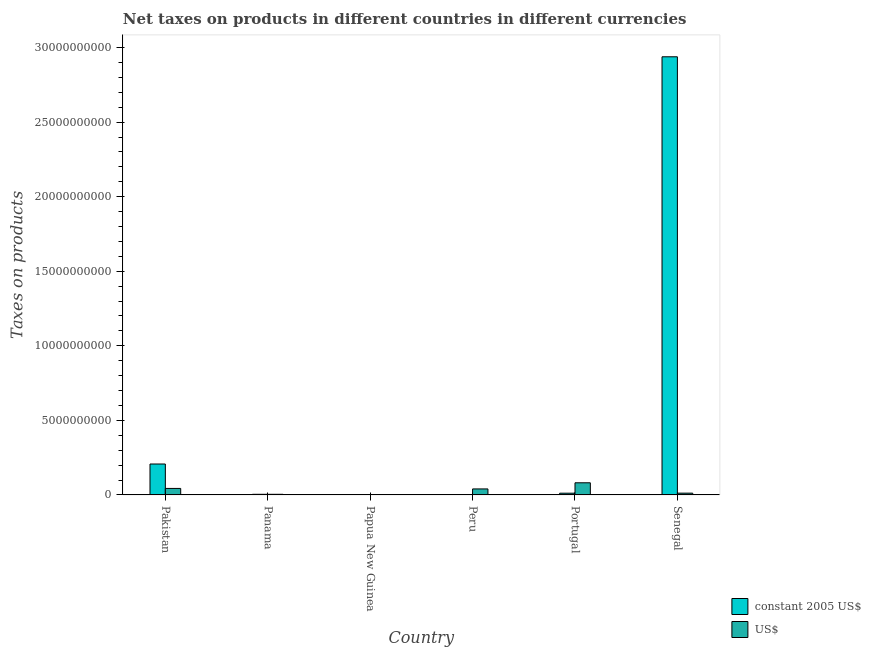How many different coloured bars are there?
Offer a terse response. 2. How many bars are there on the 3rd tick from the left?
Provide a short and direct response. 2. What is the label of the 6th group of bars from the left?
Make the answer very short. Senegal. In how many cases, is the number of bars for a given country not equal to the number of legend labels?
Your answer should be compact. 0. What is the net taxes in constant 2005 us$ in Panama?
Provide a short and direct response. 4.20e+07. Across all countries, what is the maximum net taxes in us$?
Provide a succinct answer. 8.14e+08. Across all countries, what is the minimum net taxes in constant 2005 us$?
Your answer should be compact. 10.8. In which country was the net taxes in us$ maximum?
Your answer should be very brief. Portugal. In which country was the net taxes in us$ minimum?
Make the answer very short. Papua New Guinea. What is the total net taxes in us$ in the graph?
Offer a very short reply. 1.83e+09. What is the difference between the net taxes in us$ in Papua New Guinea and that in Peru?
Make the answer very short. -3.91e+08. What is the difference between the net taxes in constant 2005 us$ in Portugal and the net taxes in us$ in Papua New Guinea?
Offer a terse response. 1.05e+08. What is the average net taxes in constant 2005 us$ per country?
Keep it short and to the point. 5.27e+09. What is the difference between the net taxes in us$ and net taxes in constant 2005 us$ in Portugal?
Give a very brief answer. 6.98e+08. In how many countries, is the net taxes in constant 2005 us$ greater than 18000000000 units?
Offer a terse response. 1. What is the ratio of the net taxes in constant 2005 us$ in Peru to that in Senegal?
Offer a very short reply. 3.675817024414191e-10. Is the difference between the net taxes in constant 2005 us$ in Papua New Guinea and Senegal greater than the difference between the net taxes in us$ in Papua New Guinea and Senegal?
Give a very brief answer. No. What is the difference between the highest and the second highest net taxes in us$?
Your answer should be compact. 3.79e+08. What is the difference between the highest and the lowest net taxes in us$?
Your answer should be very brief. 8.03e+08. In how many countries, is the net taxes in us$ greater than the average net taxes in us$ taken over all countries?
Make the answer very short. 3. What does the 1st bar from the left in Peru represents?
Your response must be concise. Constant 2005 us$. What does the 2nd bar from the right in Peru represents?
Your answer should be very brief. Constant 2005 us$. How many bars are there?
Your response must be concise. 12. Are all the bars in the graph horizontal?
Provide a succinct answer. No. What is the difference between two consecutive major ticks on the Y-axis?
Offer a very short reply. 5.00e+09. Are the values on the major ticks of Y-axis written in scientific E-notation?
Provide a succinct answer. No. Where does the legend appear in the graph?
Your answer should be compact. Bottom right. How are the legend labels stacked?
Your answer should be compact. Vertical. What is the title of the graph?
Keep it short and to the point. Net taxes on products in different countries in different currencies. Does "Depositors" appear as one of the legend labels in the graph?
Make the answer very short. No. What is the label or title of the Y-axis?
Make the answer very short. Taxes on products. What is the Taxes on products of constant 2005 US$ in Pakistan?
Provide a short and direct response. 2.07e+09. What is the Taxes on products of US$ in Pakistan?
Ensure brevity in your answer.  4.36e+08. What is the Taxes on products of constant 2005 US$ in Panama?
Ensure brevity in your answer.  4.20e+07. What is the Taxes on products in US$ in Panama?
Your response must be concise. 4.20e+07. What is the Taxes on products in constant 2005 US$ in Papua New Guinea?
Offer a very short reply. 1.03e+07. What is the Taxes on products of US$ in Papua New Guinea?
Your answer should be very brief. 1.15e+07. What is the Taxes on products in constant 2005 US$ in Peru?
Offer a very short reply. 10.8. What is the Taxes on products of US$ in Peru?
Your answer should be very brief. 4.03e+08. What is the Taxes on products in constant 2005 US$ in Portugal?
Ensure brevity in your answer.  1.17e+08. What is the Taxes on products in US$ in Portugal?
Offer a terse response. 8.14e+08. What is the Taxes on products of constant 2005 US$ in Senegal?
Provide a succinct answer. 2.94e+1. What is the Taxes on products in US$ in Senegal?
Ensure brevity in your answer.  1.20e+08. Across all countries, what is the maximum Taxes on products of constant 2005 US$?
Your response must be concise. 2.94e+1. Across all countries, what is the maximum Taxes on products of US$?
Your response must be concise. 8.14e+08. Across all countries, what is the minimum Taxes on products of constant 2005 US$?
Make the answer very short. 10.8. Across all countries, what is the minimum Taxes on products in US$?
Give a very brief answer. 1.15e+07. What is the total Taxes on products in constant 2005 US$ in the graph?
Offer a very short reply. 3.16e+1. What is the total Taxes on products in US$ in the graph?
Offer a terse response. 1.83e+09. What is the difference between the Taxes on products in constant 2005 US$ in Pakistan and that in Panama?
Offer a terse response. 2.03e+09. What is the difference between the Taxes on products of US$ in Pakistan and that in Panama?
Your answer should be compact. 3.94e+08. What is the difference between the Taxes on products of constant 2005 US$ in Pakistan and that in Papua New Guinea?
Your response must be concise. 2.06e+09. What is the difference between the Taxes on products of US$ in Pakistan and that in Papua New Guinea?
Provide a succinct answer. 4.24e+08. What is the difference between the Taxes on products of constant 2005 US$ in Pakistan and that in Peru?
Keep it short and to the point. 2.07e+09. What is the difference between the Taxes on products in US$ in Pakistan and that in Peru?
Your response must be concise. 3.28e+07. What is the difference between the Taxes on products of constant 2005 US$ in Pakistan and that in Portugal?
Offer a terse response. 1.96e+09. What is the difference between the Taxes on products of US$ in Pakistan and that in Portugal?
Provide a succinct answer. -3.79e+08. What is the difference between the Taxes on products of constant 2005 US$ in Pakistan and that in Senegal?
Offer a terse response. -2.73e+1. What is the difference between the Taxes on products in US$ in Pakistan and that in Senegal?
Your response must be concise. 3.16e+08. What is the difference between the Taxes on products in constant 2005 US$ in Panama and that in Papua New Guinea?
Ensure brevity in your answer.  3.17e+07. What is the difference between the Taxes on products in US$ in Panama and that in Papua New Guinea?
Ensure brevity in your answer.  3.05e+07. What is the difference between the Taxes on products of constant 2005 US$ in Panama and that in Peru?
Provide a succinct answer. 4.20e+07. What is the difference between the Taxes on products in US$ in Panama and that in Peru?
Your answer should be compact. -3.61e+08. What is the difference between the Taxes on products of constant 2005 US$ in Panama and that in Portugal?
Your answer should be compact. -7.48e+07. What is the difference between the Taxes on products in US$ in Panama and that in Portugal?
Your answer should be very brief. -7.72e+08. What is the difference between the Taxes on products of constant 2005 US$ in Panama and that in Senegal?
Your response must be concise. -2.93e+1. What is the difference between the Taxes on products of US$ in Panama and that in Senegal?
Provide a short and direct response. -7.79e+07. What is the difference between the Taxes on products in constant 2005 US$ in Papua New Guinea and that in Peru?
Ensure brevity in your answer.  1.03e+07. What is the difference between the Taxes on products of US$ in Papua New Guinea and that in Peru?
Provide a succinct answer. -3.91e+08. What is the difference between the Taxes on products of constant 2005 US$ in Papua New Guinea and that in Portugal?
Make the answer very short. -1.06e+08. What is the difference between the Taxes on products in US$ in Papua New Guinea and that in Portugal?
Give a very brief answer. -8.03e+08. What is the difference between the Taxes on products in constant 2005 US$ in Papua New Guinea and that in Senegal?
Keep it short and to the point. -2.94e+1. What is the difference between the Taxes on products of US$ in Papua New Guinea and that in Senegal?
Offer a terse response. -1.08e+08. What is the difference between the Taxes on products in constant 2005 US$ in Peru and that in Portugal?
Your answer should be compact. -1.17e+08. What is the difference between the Taxes on products in US$ in Peru and that in Portugal?
Make the answer very short. -4.12e+08. What is the difference between the Taxes on products in constant 2005 US$ in Peru and that in Senegal?
Provide a succinct answer. -2.94e+1. What is the difference between the Taxes on products in US$ in Peru and that in Senegal?
Provide a succinct answer. 2.83e+08. What is the difference between the Taxes on products of constant 2005 US$ in Portugal and that in Senegal?
Offer a very short reply. -2.93e+1. What is the difference between the Taxes on products in US$ in Portugal and that in Senegal?
Your answer should be compact. 6.94e+08. What is the difference between the Taxes on products in constant 2005 US$ in Pakistan and the Taxes on products in US$ in Panama?
Your answer should be compact. 2.03e+09. What is the difference between the Taxes on products in constant 2005 US$ in Pakistan and the Taxes on products in US$ in Papua New Guinea?
Make the answer very short. 2.06e+09. What is the difference between the Taxes on products in constant 2005 US$ in Pakistan and the Taxes on products in US$ in Peru?
Give a very brief answer. 1.67e+09. What is the difference between the Taxes on products in constant 2005 US$ in Pakistan and the Taxes on products in US$ in Portugal?
Your answer should be compact. 1.26e+09. What is the difference between the Taxes on products of constant 2005 US$ in Pakistan and the Taxes on products of US$ in Senegal?
Your response must be concise. 1.95e+09. What is the difference between the Taxes on products of constant 2005 US$ in Panama and the Taxes on products of US$ in Papua New Guinea?
Provide a succinct answer. 3.05e+07. What is the difference between the Taxes on products in constant 2005 US$ in Panama and the Taxes on products in US$ in Peru?
Your answer should be very brief. -3.61e+08. What is the difference between the Taxes on products in constant 2005 US$ in Panama and the Taxes on products in US$ in Portugal?
Your answer should be very brief. -7.72e+08. What is the difference between the Taxes on products of constant 2005 US$ in Panama and the Taxes on products of US$ in Senegal?
Provide a succinct answer. -7.79e+07. What is the difference between the Taxes on products of constant 2005 US$ in Papua New Guinea and the Taxes on products of US$ in Peru?
Offer a very short reply. -3.92e+08. What is the difference between the Taxes on products in constant 2005 US$ in Papua New Guinea and the Taxes on products in US$ in Portugal?
Your answer should be compact. -8.04e+08. What is the difference between the Taxes on products in constant 2005 US$ in Papua New Guinea and the Taxes on products in US$ in Senegal?
Your response must be concise. -1.10e+08. What is the difference between the Taxes on products of constant 2005 US$ in Peru and the Taxes on products of US$ in Portugal?
Offer a very short reply. -8.14e+08. What is the difference between the Taxes on products of constant 2005 US$ in Peru and the Taxes on products of US$ in Senegal?
Your answer should be very brief. -1.20e+08. What is the difference between the Taxes on products of constant 2005 US$ in Portugal and the Taxes on products of US$ in Senegal?
Keep it short and to the point. -3.11e+06. What is the average Taxes on products of constant 2005 US$ per country?
Your answer should be very brief. 5.27e+09. What is the average Taxes on products in US$ per country?
Offer a terse response. 3.04e+08. What is the difference between the Taxes on products of constant 2005 US$ and Taxes on products of US$ in Pakistan?
Your response must be concise. 1.64e+09. What is the difference between the Taxes on products in constant 2005 US$ and Taxes on products in US$ in Panama?
Keep it short and to the point. 0. What is the difference between the Taxes on products in constant 2005 US$ and Taxes on products in US$ in Papua New Guinea?
Your answer should be compact. -1.24e+06. What is the difference between the Taxes on products in constant 2005 US$ and Taxes on products in US$ in Peru?
Provide a succinct answer. -4.03e+08. What is the difference between the Taxes on products of constant 2005 US$ and Taxes on products of US$ in Portugal?
Your response must be concise. -6.98e+08. What is the difference between the Taxes on products of constant 2005 US$ and Taxes on products of US$ in Senegal?
Your answer should be compact. 2.93e+1. What is the ratio of the Taxes on products of constant 2005 US$ in Pakistan to that in Panama?
Offer a terse response. 49.38. What is the ratio of the Taxes on products in US$ in Pakistan to that in Panama?
Keep it short and to the point. 10.37. What is the ratio of the Taxes on products in constant 2005 US$ in Pakistan to that in Papua New Guinea?
Offer a very short reply. 201.36. What is the ratio of the Taxes on products in US$ in Pakistan to that in Papua New Guinea?
Your answer should be compact. 37.76. What is the ratio of the Taxes on products in constant 2005 US$ in Pakistan to that in Peru?
Ensure brevity in your answer.  1.92e+08. What is the ratio of the Taxes on products of US$ in Pakistan to that in Peru?
Give a very brief answer. 1.08. What is the ratio of the Taxes on products of constant 2005 US$ in Pakistan to that in Portugal?
Keep it short and to the point. 17.76. What is the ratio of the Taxes on products in US$ in Pakistan to that in Portugal?
Your response must be concise. 0.53. What is the ratio of the Taxes on products of constant 2005 US$ in Pakistan to that in Senegal?
Your answer should be very brief. 0.07. What is the ratio of the Taxes on products in US$ in Pakistan to that in Senegal?
Offer a very short reply. 3.63. What is the ratio of the Taxes on products in constant 2005 US$ in Panama to that in Papua New Guinea?
Keep it short and to the point. 4.08. What is the ratio of the Taxes on products in US$ in Panama to that in Papua New Guinea?
Make the answer very short. 3.64. What is the ratio of the Taxes on products in constant 2005 US$ in Panama to that in Peru?
Your answer should be compact. 3.89e+06. What is the ratio of the Taxes on products in US$ in Panama to that in Peru?
Ensure brevity in your answer.  0.1. What is the ratio of the Taxes on products of constant 2005 US$ in Panama to that in Portugal?
Offer a terse response. 0.36. What is the ratio of the Taxes on products of US$ in Panama to that in Portugal?
Give a very brief answer. 0.05. What is the ratio of the Taxes on products in constant 2005 US$ in Panama to that in Senegal?
Keep it short and to the point. 0. What is the ratio of the Taxes on products of US$ in Panama to that in Senegal?
Provide a short and direct response. 0.35. What is the ratio of the Taxes on products in constant 2005 US$ in Papua New Guinea to that in Peru?
Make the answer very short. 9.54e+05. What is the ratio of the Taxes on products in US$ in Papua New Guinea to that in Peru?
Your response must be concise. 0.03. What is the ratio of the Taxes on products in constant 2005 US$ in Papua New Guinea to that in Portugal?
Your answer should be compact. 0.09. What is the ratio of the Taxes on products in US$ in Papua New Guinea to that in Portugal?
Your answer should be compact. 0.01. What is the ratio of the Taxes on products in constant 2005 US$ in Papua New Guinea to that in Senegal?
Offer a very short reply. 0. What is the ratio of the Taxes on products in US$ in Papua New Guinea to that in Senegal?
Give a very brief answer. 0.1. What is the ratio of the Taxes on products in constant 2005 US$ in Peru to that in Portugal?
Ensure brevity in your answer.  0. What is the ratio of the Taxes on products in US$ in Peru to that in Portugal?
Your answer should be compact. 0.49. What is the ratio of the Taxes on products of constant 2005 US$ in Peru to that in Senegal?
Provide a succinct answer. 0. What is the ratio of the Taxes on products of US$ in Peru to that in Senegal?
Offer a very short reply. 3.36. What is the ratio of the Taxes on products of constant 2005 US$ in Portugal to that in Senegal?
Provide a succinct answer. 0. What is the ratio of the Taxes on products of US$ in Portugal to that in Senegal?
Offer a very short reply. 6.79. What is the difference between the highest and the second highest Taxes on products of constant 2005 US$?
Your answer should be very brief. 2.73e+1. What is the difference between the highest and the second highest Taxes on products of US$?
Ensure brevity in your answer.  3.79e+08. What is the difference between the highest and the lowest Taxes on products of constant 2005 US$?
Your answer should be compact. 2.94e+1. What is the difference between the highest and the lowest Taxes on products in US$?
Your response must be concise. 8.03e+08. 